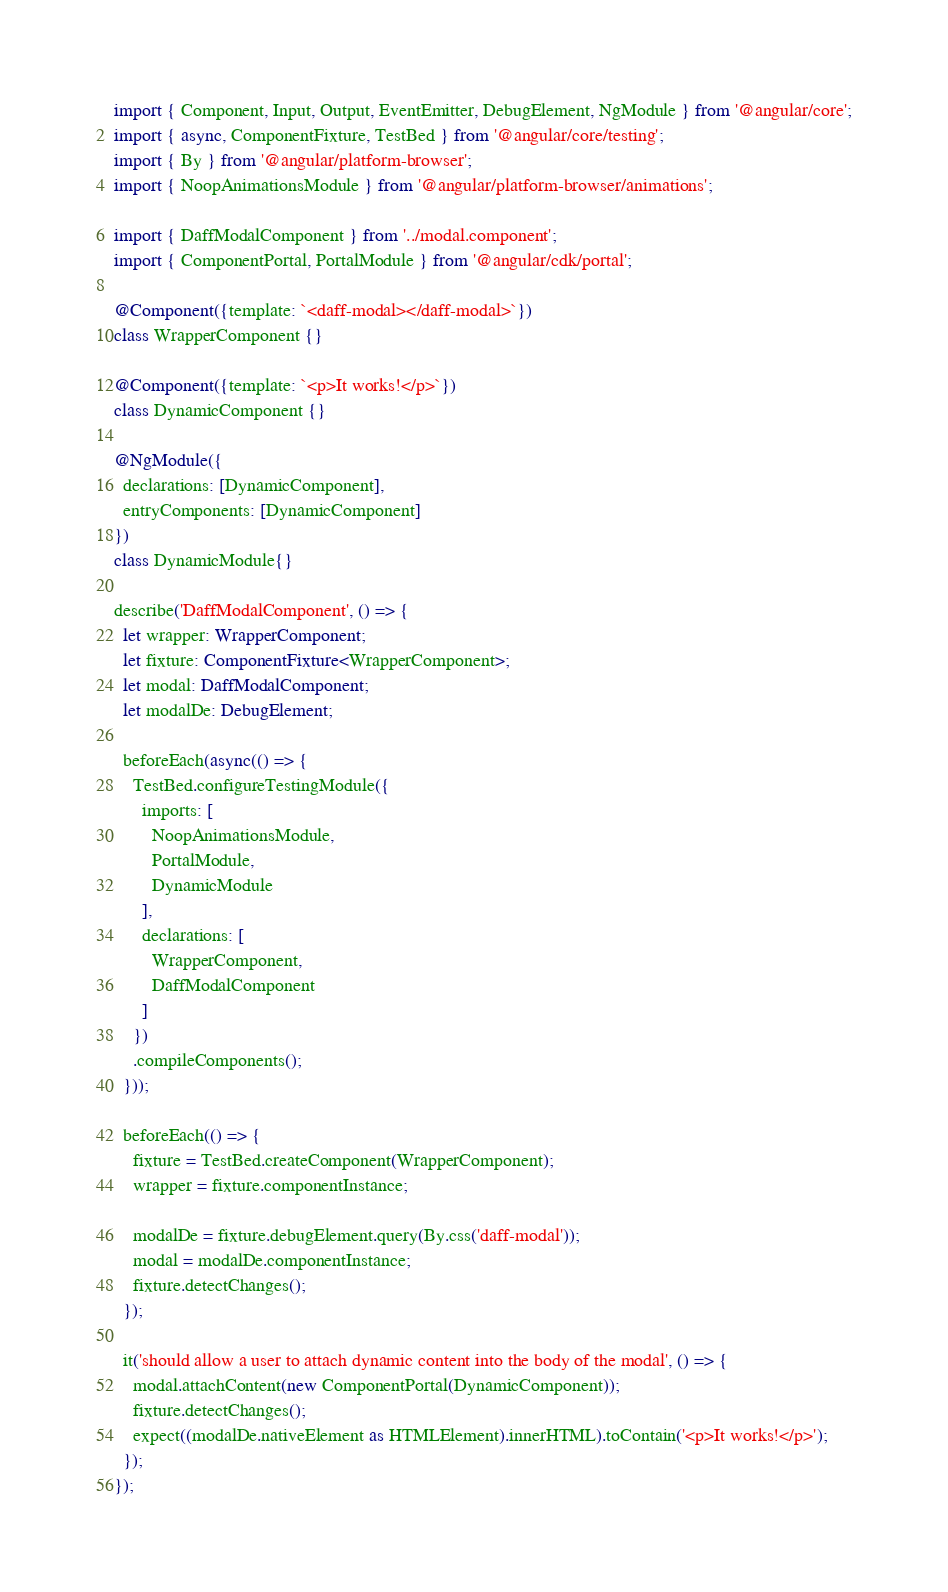Convert code to text. <code><loc_0><loc_0><loc_500><loc_500><_TypeScript_>import { Component, Input, Output, EventEmitter, DebugElement, NgModule } from '@angular/core';
import { async, ComponentFixture, TestBed } from '@angular/core/testing';
import { By } from '@angular/platform-browser';
import { NoopAnimationsModule } from '@angular/platform-browser/animations';

import { DaffModalComponent } from '../modal.component';
import { ComponentPortal, PortalModule } from '@angular/cdk/portal';

@Component({template: `<daff-modal></daff-modal>`})
class WrapperComponent {}

@Component({template: `<p>It works!</p>`})
class DynamicComponent {}

@NgModule({
  declarations: [DynamicComponent],
  entryComponents: [DynamicComponent]
})
class DynamicModule{}

describe('DaffModalComponent', () => {
  let wrapper: WrapperComponent;
  let fixture: ComponentFixture<WrapperComponent>;
  let modal: DaffModalComponent;
  let modalDe: DebugElement;
  
  beforeEach(async(() => {
    TestBed.configureTestingModule({
      imports: [
        NoopAnimationsModule,
        PortalModule,
        DynamicModule
      ],
      declarations: [
        WrapperComponent,
        DaffModalComponent
      ]
    })
    .compileComponents();
  }));

  beforeEach(() => {
    fixture = TestBed.createComponent(WrapperComponent);
    wrapper = fixture.componentInstance;

    modalDe = fixture.debugElement.query(By.css('daff-modal'));
    modal = modalDe.componentInstance;
    fixture.detectChanges();
  });

  it('should allow a user to attach dynamic content into the body of the modal', () => {
    modal.attachContent(new ComponentPortal(DynamicComponent));
    fixture.detectChanges();
    expect((modalDe.nativeElement as HTMLElement).innerHTML).toContain('<p>It works!</p>');
  });
});</code> 